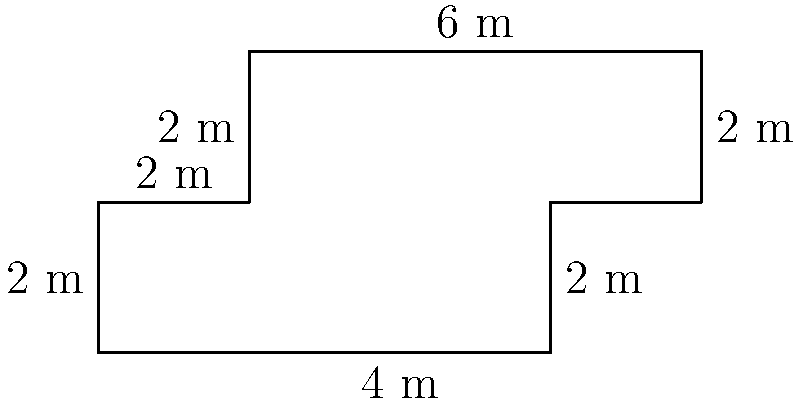Your carpenter friend has crafted a unique wooden table top for your pottery studio. The table top has an irregular shape, as shown in the diagram. Calculate the perimeter of this table top in meters. To find the perimeter of the irregularly shaped table top, we need to add up all the side lengths:

1. Start from the bottom left corner and move clockwise:
   - Bottom side: $4$ m
   - Right side (lower): $2$ m
   - Small top extension: $2$ m
   - Right side (upper): $2$ m
   - Top side: $6$ m
   - Left side (upper): $2$ m
   - Small left indentation: $2$ m
   - Left side (lower): $2$ m

2. Add all these lengths together:
   $$ 4 + 2 + 2 + 2 + 6 + 2 + 2 + 2 = 22 $$

Therefore, the perimeter of the table top is $22$ meters.
Answer: $22$ m 